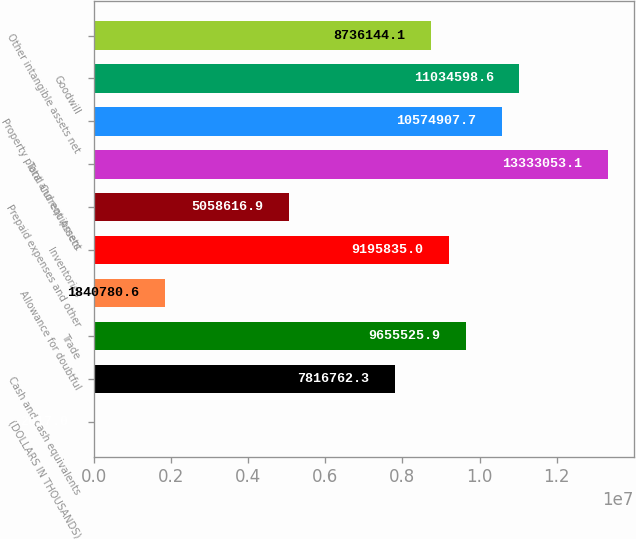Convert chart. <chart><loc_0><loc_0><loc_500><loc_500><bar_chart><fcel>(DOLLARS IN THOUSANDS)<fcel>Cash and cash equivalents<fcel>Trade<fcel>Allowance for doubtful<fcel>Inventories<fcel>Prepaid expenses and other<fcel>Total Current Assets<fcel>Property plant and equipment<fcel>Goodwill<fcel>Other intangible assets net<nl><fcel>2017<fcel>7.81676e+06<fcel>9.65553e+06<fcel>1.84078e+06<fcel>9.19584e+06<fcel>5.05862e+06<fcel>1.33331e+07<fcel>1.05749e+07<fcel>1.10346e+07<fcel>8.73614e+06<nl></chart> 